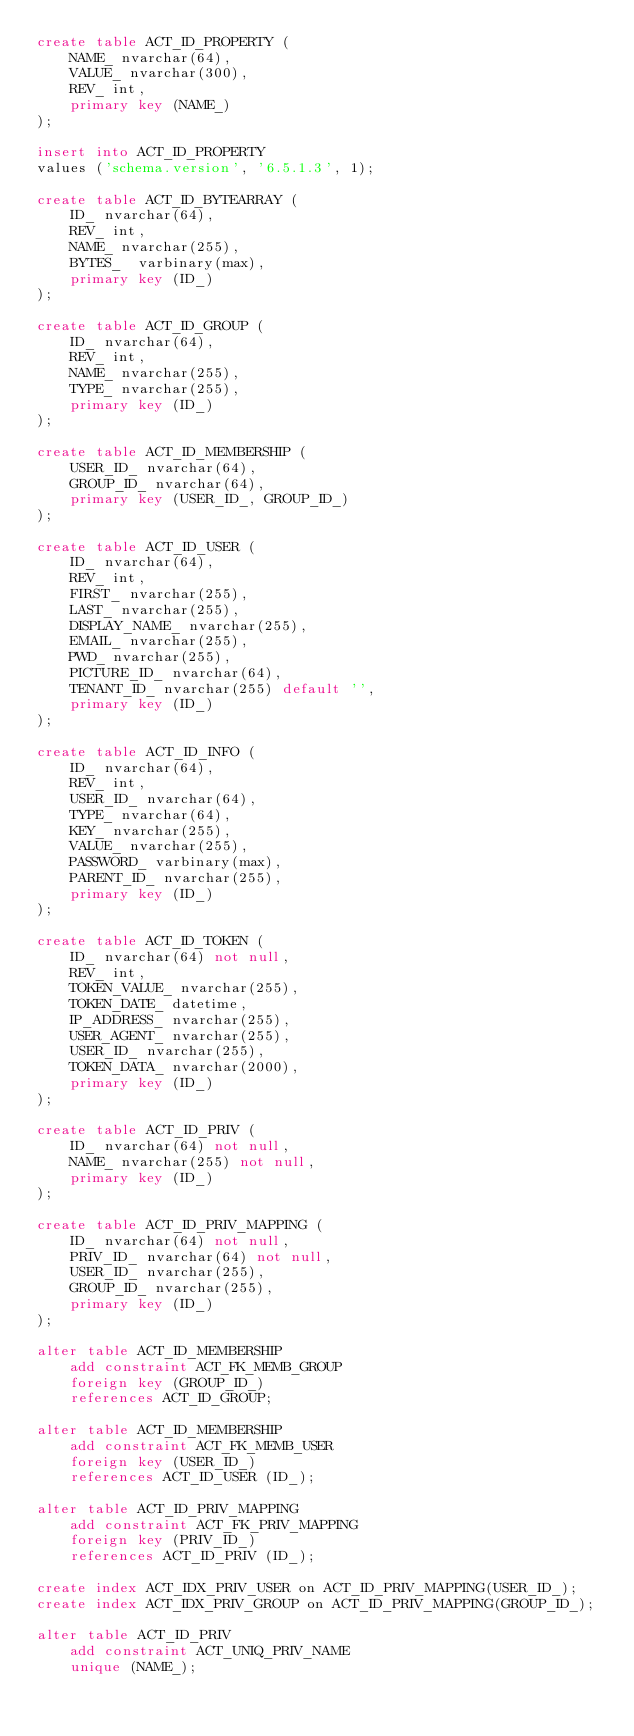Convert code to text. <code><loc_0><loc_0><loc_500><loc_500><_SQL_>create table ACT_ID_PROPERTY (
    NAME_ nvarchar(64),
    VALUE_ nvarchar(300),
    REV_ int,
    primary key (NAME_)
);

insert into ACT_ID_PROPERTY
values ('schema.version', '6.5.1.3', 1);

create table ACT_ID_BYTEARRAY (
    ID_ nvarchar(64),
    REV_ int,
    NAME_ nvarchar(255),
    BYTES_  varbinary(max),
    primary key (ID_)
);

create table ACT_ID_GROUP (
    ID_ nvarchar(64),
    REV_ int,
    NAME_ nvarchar(255),
    TYPE_ nvarchar(255),
    primary key (ID_)
);

create table ACT_ID_MEMBERSHIP (
    USER_ID_ nvarchar(64),
    GROUP_ID_ nvarchar(64),
    primary key (USER_ID_, GROUP_ID_)
);

create table ACT_ID_USER (
    ID_ nvarchar(64),
    REV_ int,
    FIRST_ nvarchar(255),
    LAST_ nvarchar(255),
    DISPLAY_NAME_ nvarchar(255),
    EMAIL_ nvarchar(255),
    PWD_ nvarchar(255),
    PICTURE_ID_ nvarchar(64),
    TENANT_ID_ nvarchar(255) default '',
    primary key (ID_)
);

create table ACT_ID_INFO (
    ID_ nvarchar(64),
    REV_ int,
    USER_ID_ nvarchar(64),
    TYPE_ nvarchar(64),
    KEY_ nvarchar(255),
    VALUE_ nvarchar(255),
    PASSWORD_ varbinary(max),
    PARENT_ID_ nvarchar(255),
    primary key (ID_)
);

create table ACT_ID_TOKEN (
    ID_ nvarchar(64) not null,
    REV_ int,
    TOKEN_VALUE_ nvarchar(255),
    TOKEN_DATE_ datetime,
    IP_ADDRESS_ nvarchar(255),
    USER_AGENT_ nvarchar(255),
    USER_ID_ nvarchar(255),
    TOKEN_DATA_ nvarchar(2000),
    primary key (ID_)
);

create table ACT_ID_PRIV (
    ID_ nvarchar(64) not null,
    NAME_ nvarchar(255) not null,
    primary key (ID_)
);

create table ACT_ID_PRIV_MAPPING (
    ID_ nvarchar(64) not null,
    PRIV_ID_ nvarchar(64) not null,
    USER_ID_ nvarchar(255),
    GROUP_ID_ nvarchar(255),
    primary key (ID_)
);

alter table ACT_ID_MEMBERSHIP
    add constraint ACT_FK_MEMB_GROUP
    foreign key (GROUP_ID_)
    references ACT_ID_GROUP;

alter table ACT_ID_MEMBERSHIP
    add constraint ACT_FK_MEMB_USER
    foreign key (USER_ID_)
    references ACT_ID_USER (ID_);

alter table ACT_ID_PRIV_MAPPING
    add constraint ACT_FK_PRIV_MAPPING
    foreign key (PRIV_ID_)
    references ACT_ID_PRIV (ID_);

create index ACT_IDX_PRIV_USER on ACT_ID_PRIV_MAPPING(USER_ID_);
create index ACT_IDX_PRIV_GROUP on ACT_ID_PRIV_MAPPING(GROUP_ID_);

alter table ACT_ID_PRIV
    add constraint ACT_UNIQ_PRIV_NAME
    unique (NAME_);
</code> 